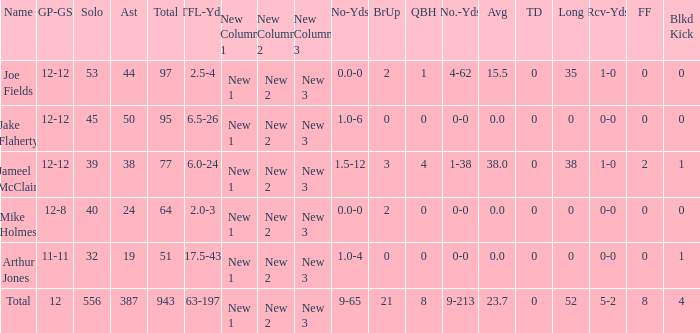What is the largest number of tds scored for a player? 0.0. 